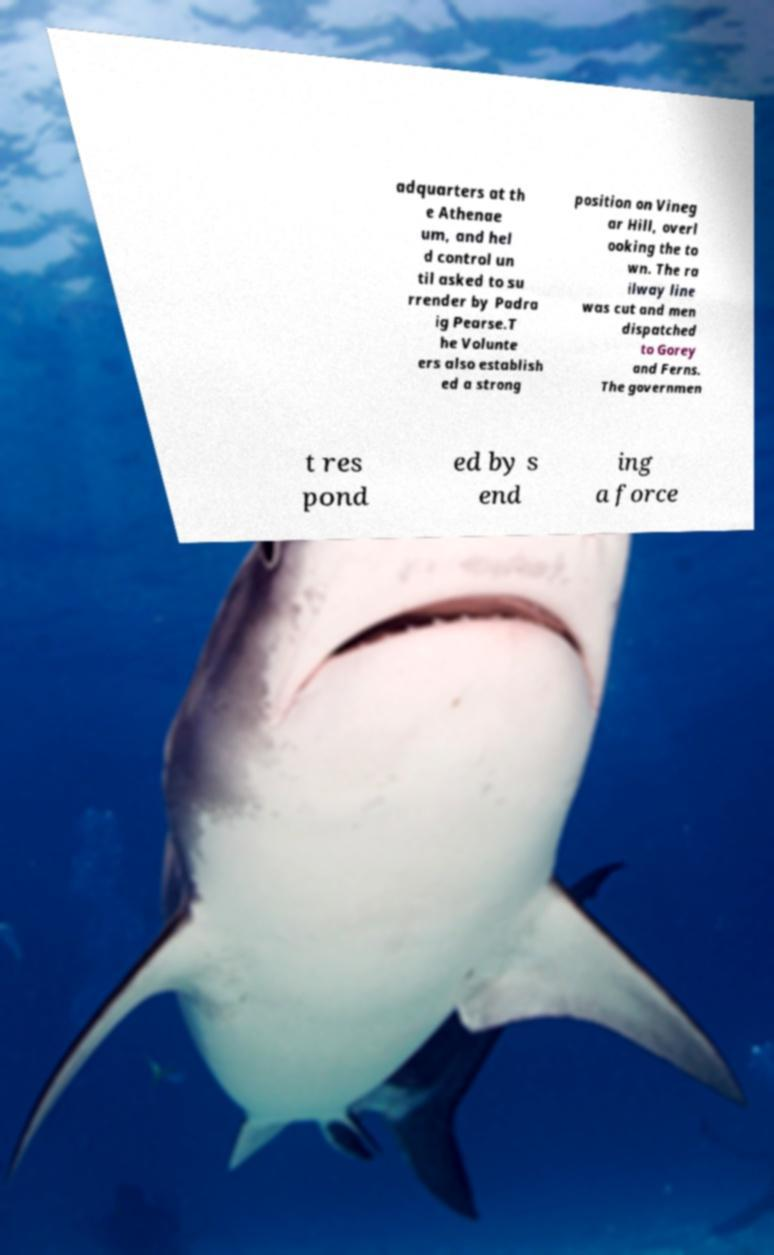What messages or text are displayed in this image? I need them in a readable, typed format. adquarters at th e Athenae um, and hel d control un til asked to su rrender by Padra ig Pearse.T he Volunte ers also establish ed a strong position on Vineg ar Hill, overl ooking the to wn. The ra ilway line was cut and men dispatched to Gorey and Ferns. The governmen t res pond ed by s end ing a force 